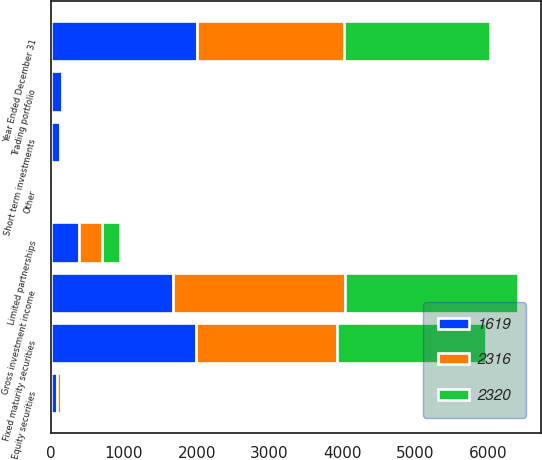<chart> <loc_0><loc_0><loc_500><loc_500><stacked_bar_chart><ecel><fcel>Year Ended December 31<fcel>Fixed maturity securities<fcel>Short term investments<fcel>Limited partnerships<fcel>Equity securities<fcel>Trading portfolio<fcel>Other<fcel>Gross investment income<nl><fcel>2320<fcel>2010<fcel>2051<fcel>15<fcel>249<fcel>32<fcel>13<fcel>10<fcel>2370<nl><fcel>2316<fcel>2009<fcel>1941<fcel>36<fcel>315<fcel>49<fcel>23<fcel>6<fcel>2370<nl><fcel>1619<fcel>2008<fcel>1984<fcel>115<fcel>379<fcel>80<fcel>149<fcel>19<fcel>1670<nl></chart> 